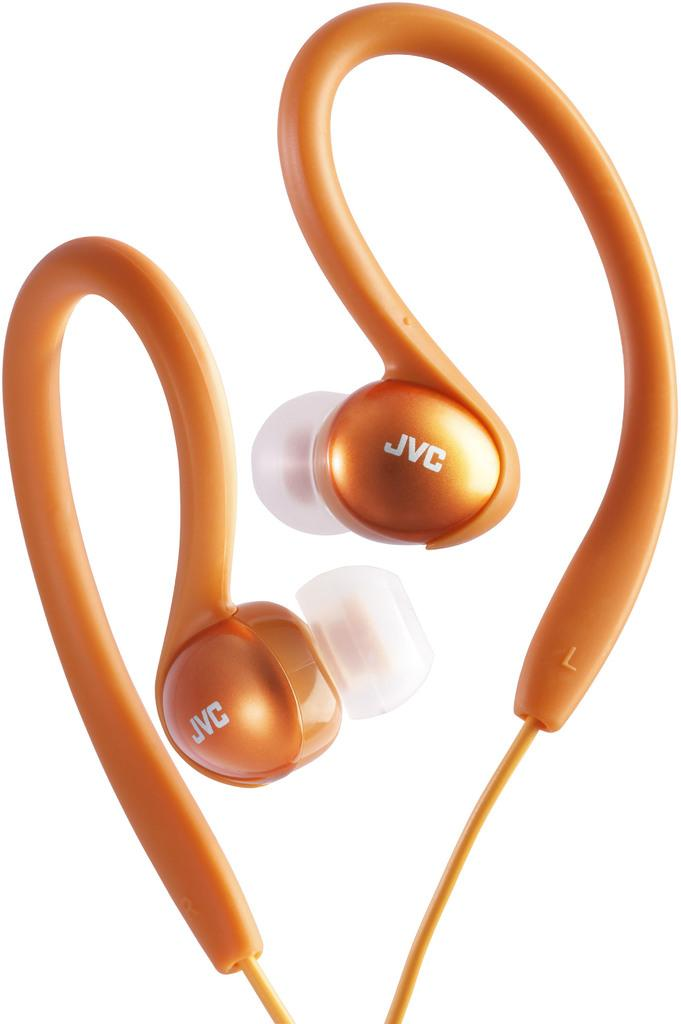<image>
Create a compact narrative representing the image presented. A pair of orange colored JVC earphones that curve over the top of ears. 